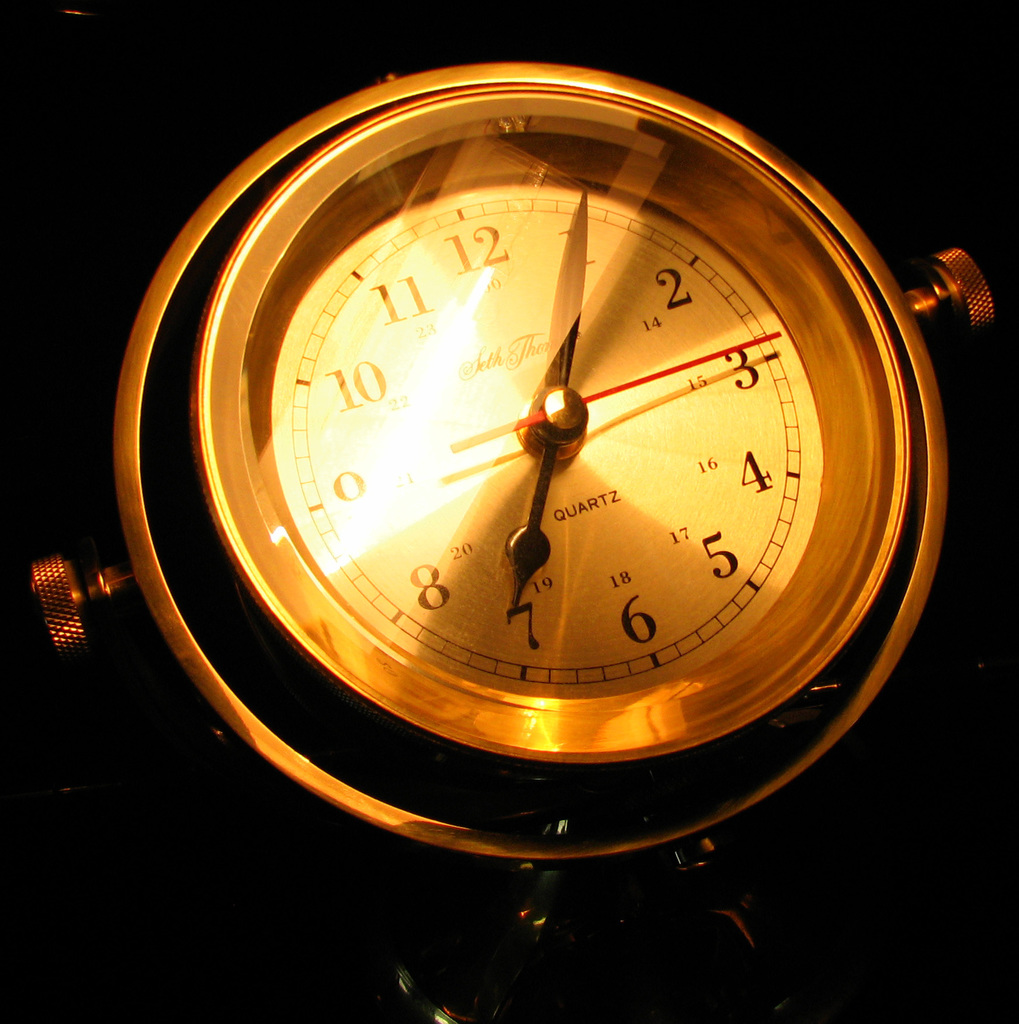Provide a one-sentence caption for the provided image.
Reference OCR token: 11, 2, 10, 4, QUARTZ, 5, 8, 6 The image showcases a classic Seth Thomas wall clock illuminated in warm light, highlighting its elegant gold-toned face and quartz movement, which offers precision and reliability. 